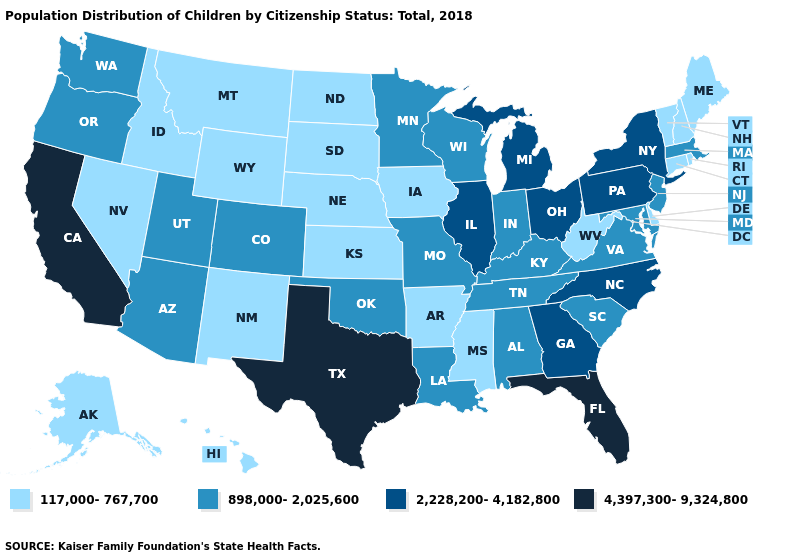What is the lowest value in states that border New Jersey?
Concise answer only. 117,000-767,700. Does the first symbol in the legend represent the smallest category?
Answer briefly. Yes. Among the states that border Pennsylvania , which have the lowest value?
Short answer required. Delaware, West Virginia. What is the value of Vermont?
Write a very short answer. 117,000-767,700. Name the states that have a value in the range 117,000-767,700?
Concise answer only. Alaska, Arkansas, Connecticut, Delaware, Hawaii, Idaho, Iowa, Kansas, Maine, Mississippi, Montana, Nebraska, Nevada, New Hampshire, New Mexico, North Dakota, Rhode Island, South Dakota, Vermont, West Virginia, Wyoming. What is the value of North Dakota?
Quick response, please. 117,000-767,700. Name the states that have a value in the range 2,228,200-4,182,800?
Give a very brief answer. Georgia, Illinois, Michigan, New York, North Carolina, Ohio, Pennsylvania. Does the first symbol in the legend represent the smallest category?
Answer briefly. Yes. What is the value of Colorado?
Quick response, please. 898,000-2,025,600. Name the states that have a value in the range 4,397,300-9,324,800?
Keep it brief. California, Florida, Texas. Does New York have a lower value than South Dakota?
Be succinct. No. Name the states that have a value in the range 4,397,300-9,324,800?
Write a very short answer. California, Florida, Texas. Among the states that border Texas , does New Mexico have the lowest value?
Answer briefly. Yes. Name the states that have a value in the range 4,397,300-9,324,800?
Give a very brief answer. California, Florida, Texas. How many symbols are there in the legend?
Answer briefly. 4. 